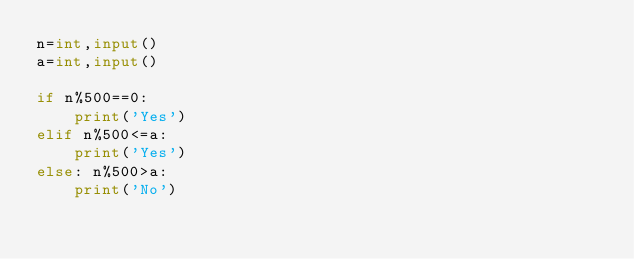Convert code to text. <code><loc_0><loc_0><loc_500><loc_500><_Python_>n=int,input()
a=int,input()

if n%500==0:
    print('Yes')
elif n%500<=a:
    print('Yes')
else: n%500>a:
    print('No')</code> 